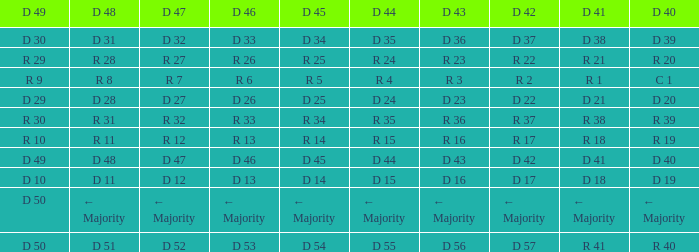Tell me the D 49 and D 46 of r 13 R 10. 